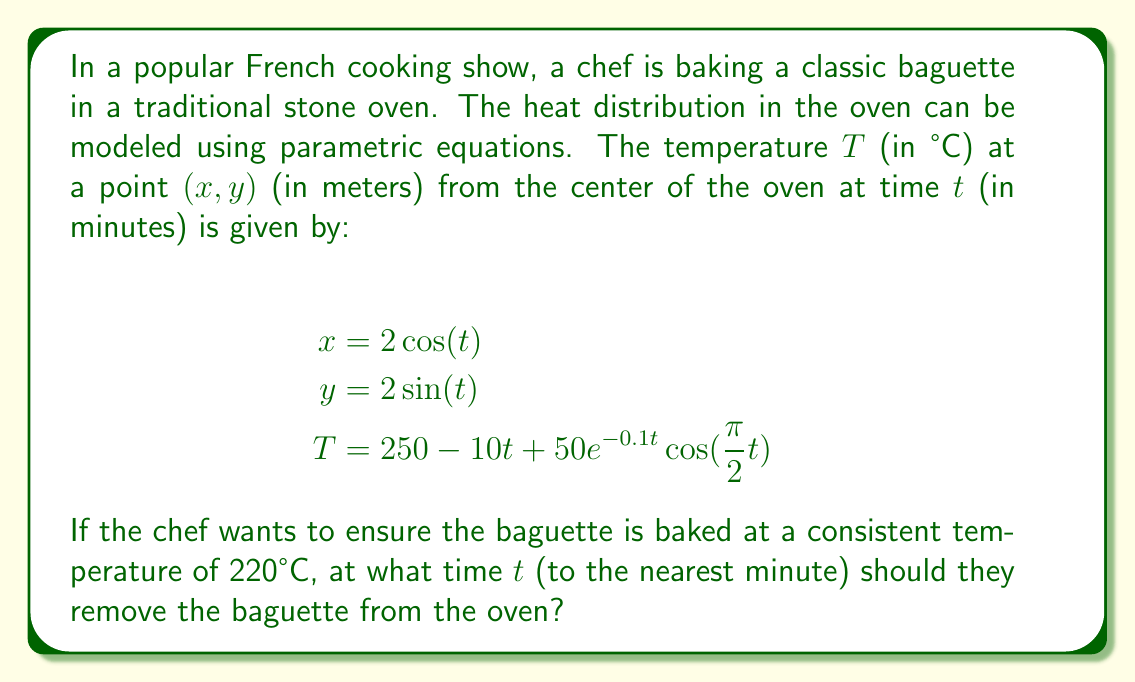Could you help me with this problem? To solve this problem, we need to follow these steps:

1) The temperature function $T$ is independent of $x$ and $y$, so we can focus solely on the equation:

   $$T = 250 - 10t + 50e^{-0.1t}\cos(\frac{\pi}{2}t)$$

2) We need to find $t$ when $T = 220°C$. This gives us the equation:

   $$220 = 250 - 10t + 50e^{-0.1t}\cos(\frac{\pi}{2}t)$$

3) Rearranging the equation:

   $$50e^{-0.1t}\cos(\frac{\pi}{2}t) = 220 - 250 + 10t$$
   $$50e^{-0.1t}\cos(\frac{\pi}{2}t) = -30 + 10t$$

4) This equation is transcendental and cannot be solved algebraically. We need to use numerical methods or graphing to find the solution.

5) Using a graphing calculator or computer software, we can plot both sides of the equation:

   $$y_1 = 50e^{-0.1t}\cos(\frac{\pi}{2}t)$$
   $$y_2 = -30 + 10t$$

6) The intersection point of these two curves will give us the value of $t$ we're looking for.

7) The intersection occurs at approximately $t = 3.76$ minutes.

8) Rounding to the nearest minute, we get $t = 4$ minutes.
Answer: The chef should remove the baguette from the oven after approximately 4 minutes to ensure it is baked at a consistent temperature of 220°C. 